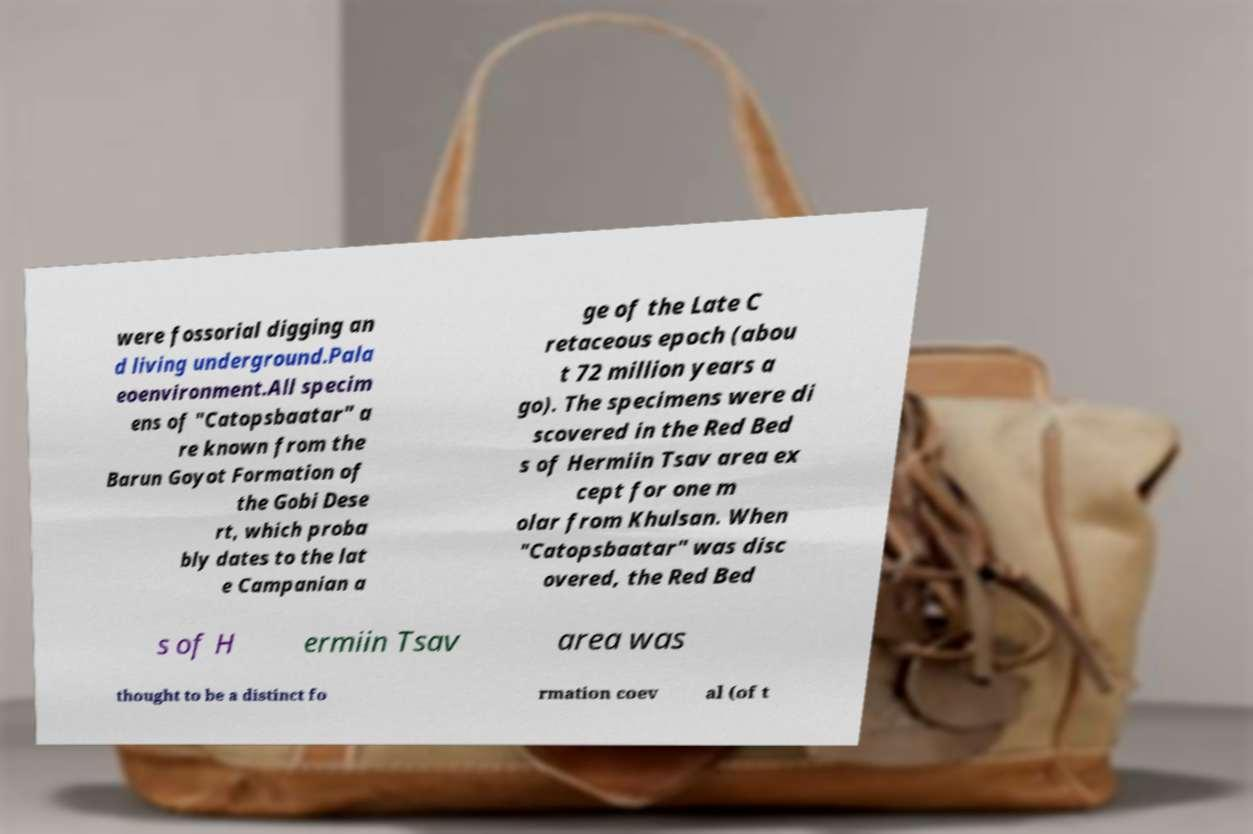Could you extract and type out the text from this image? were fossorial digging an d living underground.Pala eoenvironment.All specim ens of "Catopsbaatar" a re known from the Barun Goyot Formation of the Gobi Dese rt, which proba bly dates to the lat e Campanian a ge of the Late C retaceous epoch (abou t 72 million years a go). The specimens were di scovered in the Red Bed s of Hermiin Tsav area ex cept for one m olar from Khulsan. When "Catopsbaatar" was disc overed, the Red Bed s of H ermiin Tsav area was thought to be a distinct fo rmation coev al (of t 